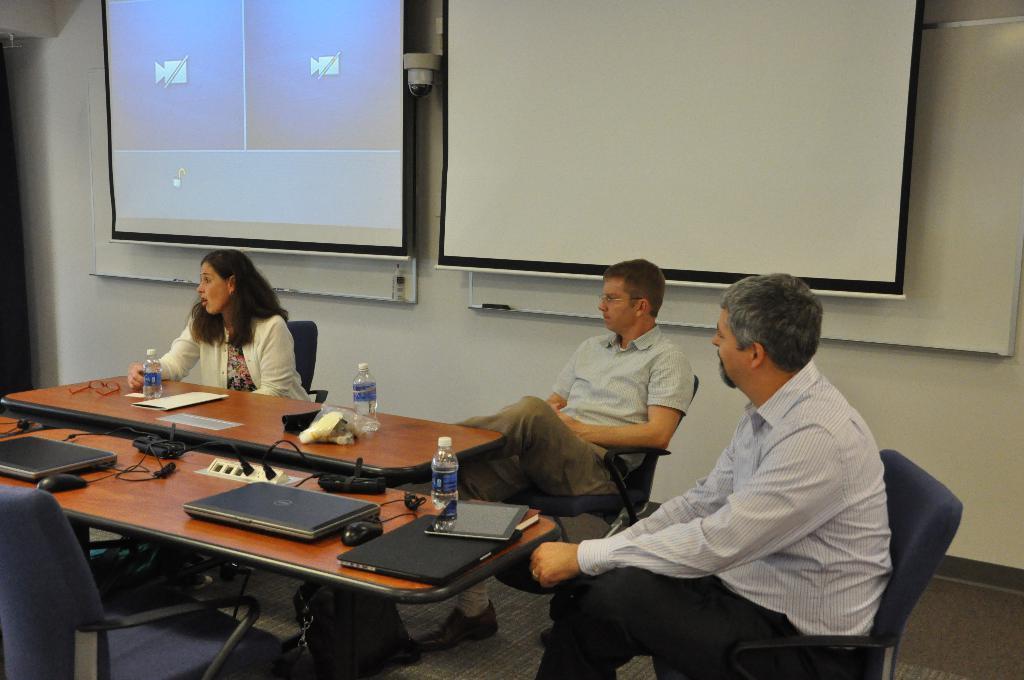Describe this image in one or two sentences. In this image i can see a woman and two man sitting on a chair there are three laptops, three bottles a paper on a table at the back ground i can see two projectors and a wall. 